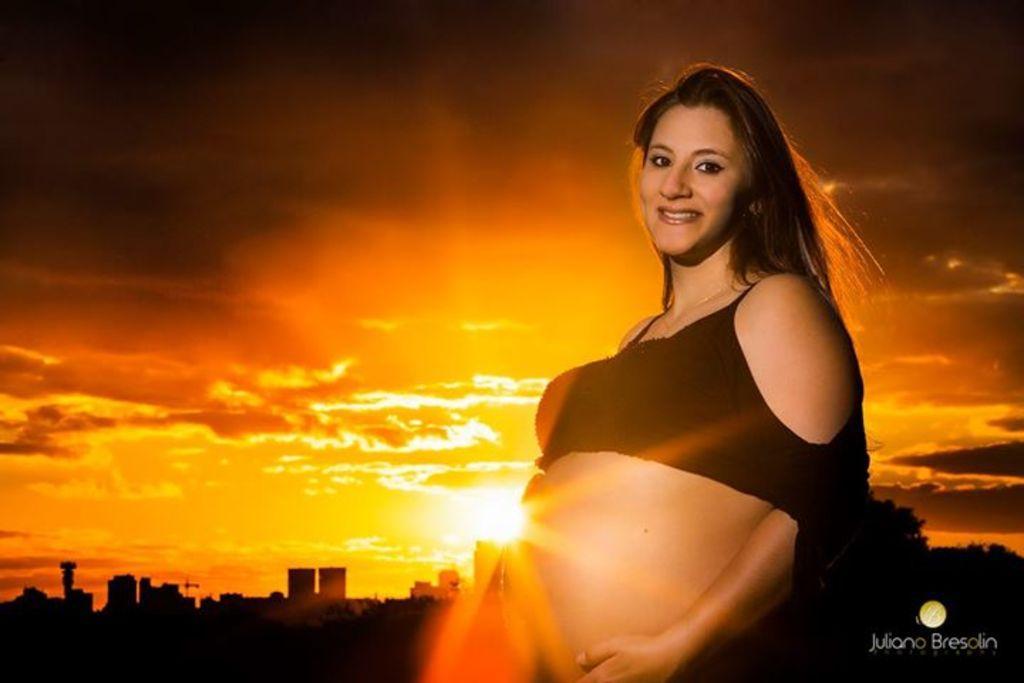Could you give a brief overview of what you see in this image? In the foreground of this image, there is a woman. In the background, there are buildings, sun and the sky. 